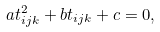<formula> <loc_0><loc_0><loc_500><loc_500>a t _ { i j k } ^ { 2 } + b t _ { i j k } + c = 0 ,</formula> 